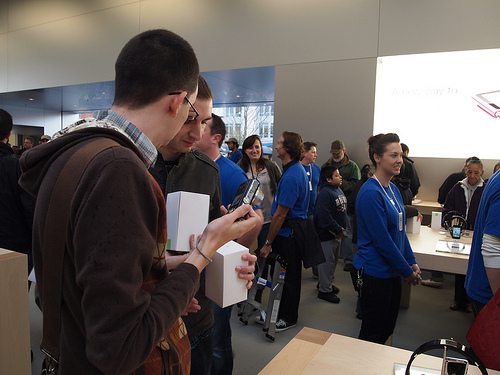<image>
Can you confirm if the table is behind the woman? No. The table is not behind the woman. From this viewpoint, the table appears to be positioned elsewhere in the scene. 